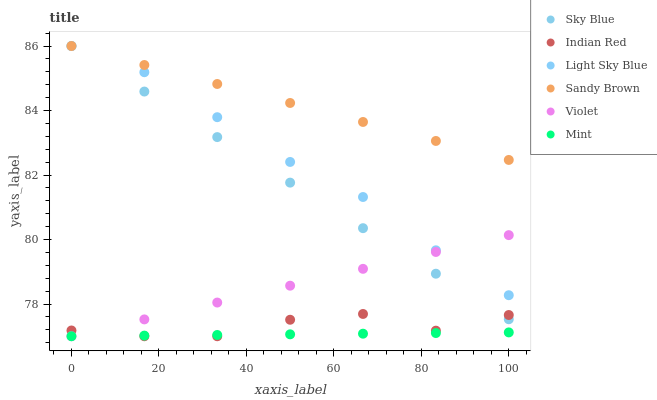Does Mint have the minimum area under the curve?
Answer yes or no. Yes. Does Sandy Brown have the maximum area under the curve?
Answer yes or no. Yes. Does Light Sky Blue have the minimum area under the curve?
Answer yes or no. No. Does Light Sky Blue have the maximum area under the curve?
Answer yes or no. No. Is Mint the smoothest?
Answer yes or no. Yes. Is Indian Red the roughest?
Answer yes or no. Yes. Is Light Sky Blue the smoothest?
Answer yes or no. No. Is Light Sky Blue the roughest?
Answer yes or no. No. Does Mint have the lowest value?
Answer yes or no. Yes. Does Light Sky Blue have the lowest value?
Answer yes or no. No. Does Sandy Brown have the highest value?
Answer yes or no. Yes. Does Indian Red have the highest value?
Answer yes or no. No. Is Mint less than Light Sky Blue?
Answer yes or no. Yes. Is Sky Blue greater than Mint?
Answer yes or no. Yes. Does Light Sky Blue intersect Violet?
Answer yes or no. Yes. Is Light Sky Blue less than Violet?
Answer yes or no. No. Is Light Sky Blue greater than Violet?
Answer yes or no. No. Does Mint intersect Light Sky Blue?
Answer yes or no. No. 